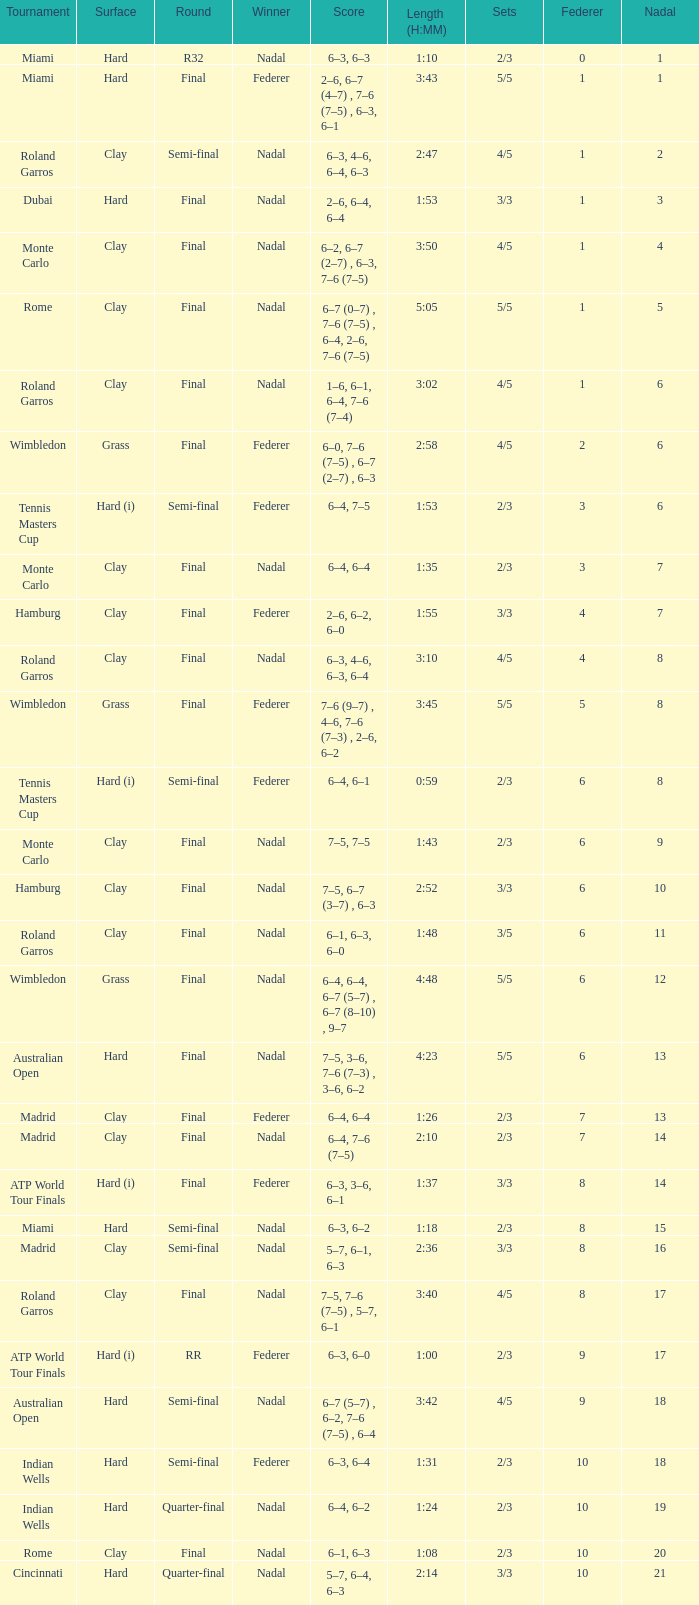How did nadal perform in the final round in miami? 1.0. 